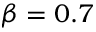Convert formula to latex. <formula><loc_0><loc_0><loc_500><loc_500>\beta = 0 . 7</formula> 